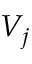<formula> <loc_0><loc_0><loc_500><loc_500>V _ { j }</formula> 